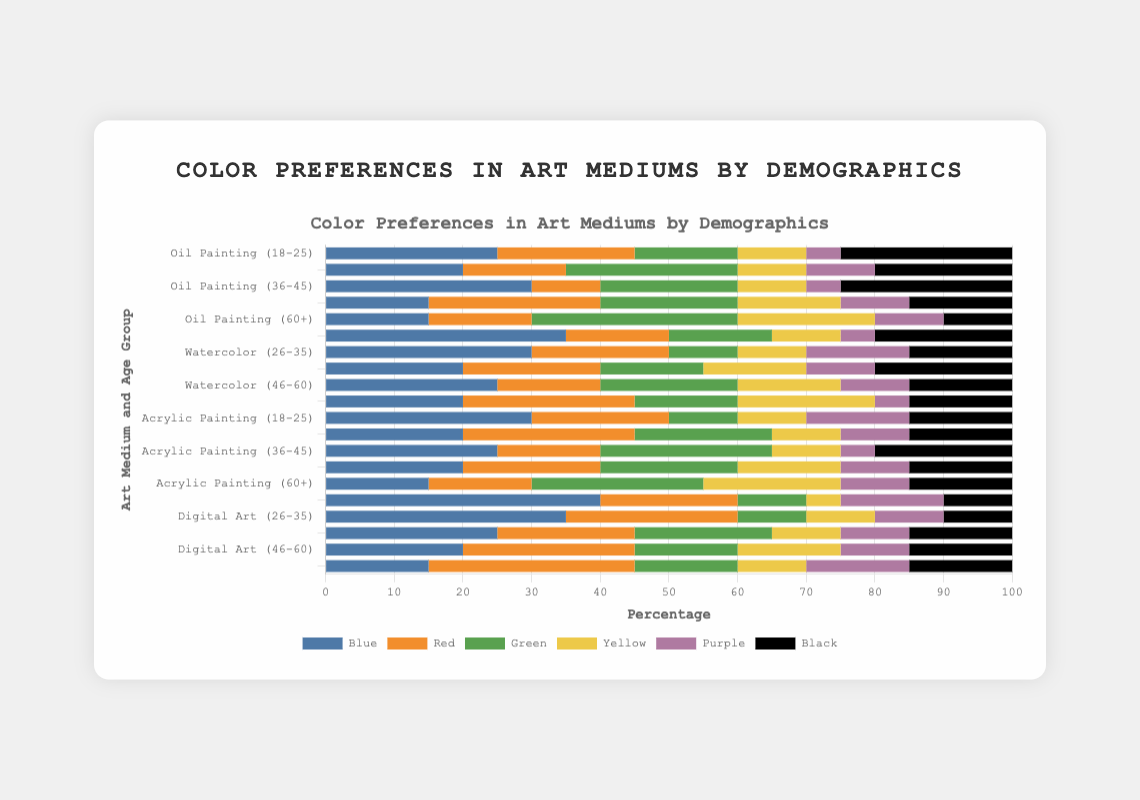What is the most preferred color for Oil Painting among the 18-25 age group? The bar representing Oil Painting among the 18-25 age group is analyzed. The highest segment is for Blue, indicating it is the most preferred color among this subgroup.
Answer: Blue Which age group prefers Black the most in Watercolor? The bar segments for Black across different age groups within Watercolor are compared. The 18-25 age group has the largest segment for Black.
Answer: 18-25 Among the 36-45 age group, which art medium has the highest preference for Blue? The Blue segment across different art mediums in the 36-45 age group is compared. Oil Painting has the tallest Blue segment.
Answer: Oil Painting What is the least preferred color in Digital Art among the 26-35 age group? The bar segments for Digital Art among the 26-35 age group are analyzed. The smallest segment is for Black.
Answer: Black For Acrylic Painting, among the 60+ age group, which colors equally share the third most preferred position? The bar segments for Acrylic Painting among the 60+ age group are analyzed. Red, Purple, and Black each have equal segments sharing the third most preferred position.
Answer: Red, Purple, Black What is the combined preference percentage for Blue and Red in Oil Painting among the 36-45 age group? Add the percentage values for Blue and Red segments in Oil Painting for the 36-45 age group: 30 + 10 = 40.
Answer: 40 How does the preference for Green in the 46-60 age group compare between Oil Painting and Digital Art? Compare the Green segments for Oil Painting and Digital Art in the 46-60 age group. Both segments are equal in length, indicating equal preference.
Answer: Equal What is the rank of Purple in terms of preference in all age groups for Watercolor? For each age group, the Purple segment is compared with other colors in Watercolor. Purple ranks fifth in 18-25, second in 26-35, fourth in 36-45, fourth in 46-60, and fifth in 60+. Summarizing these, Purple's overall rank averages around the fourth position.
Answer: Fourth 